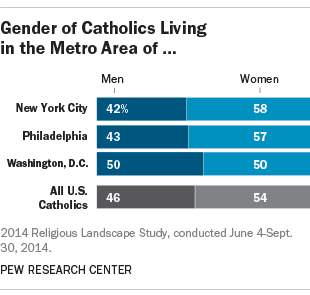What does this chart tell us about gender distribution among Catholics in the respective metro areas compared to the national average? The chart illustrates the gender distribution of the Catholic population in three metro areas: New York City, Philadelphia, and Washington, D.C., in comparison to the national average for U.S. Catholics. It indicates that in these specific areas, women constitute a higher percentage of the Catholic population than men when compared to the national average, wherein women make up 54% and men 46%. Notably, Washington D.C. has an even distribution with a 50-50 split between men and women. 